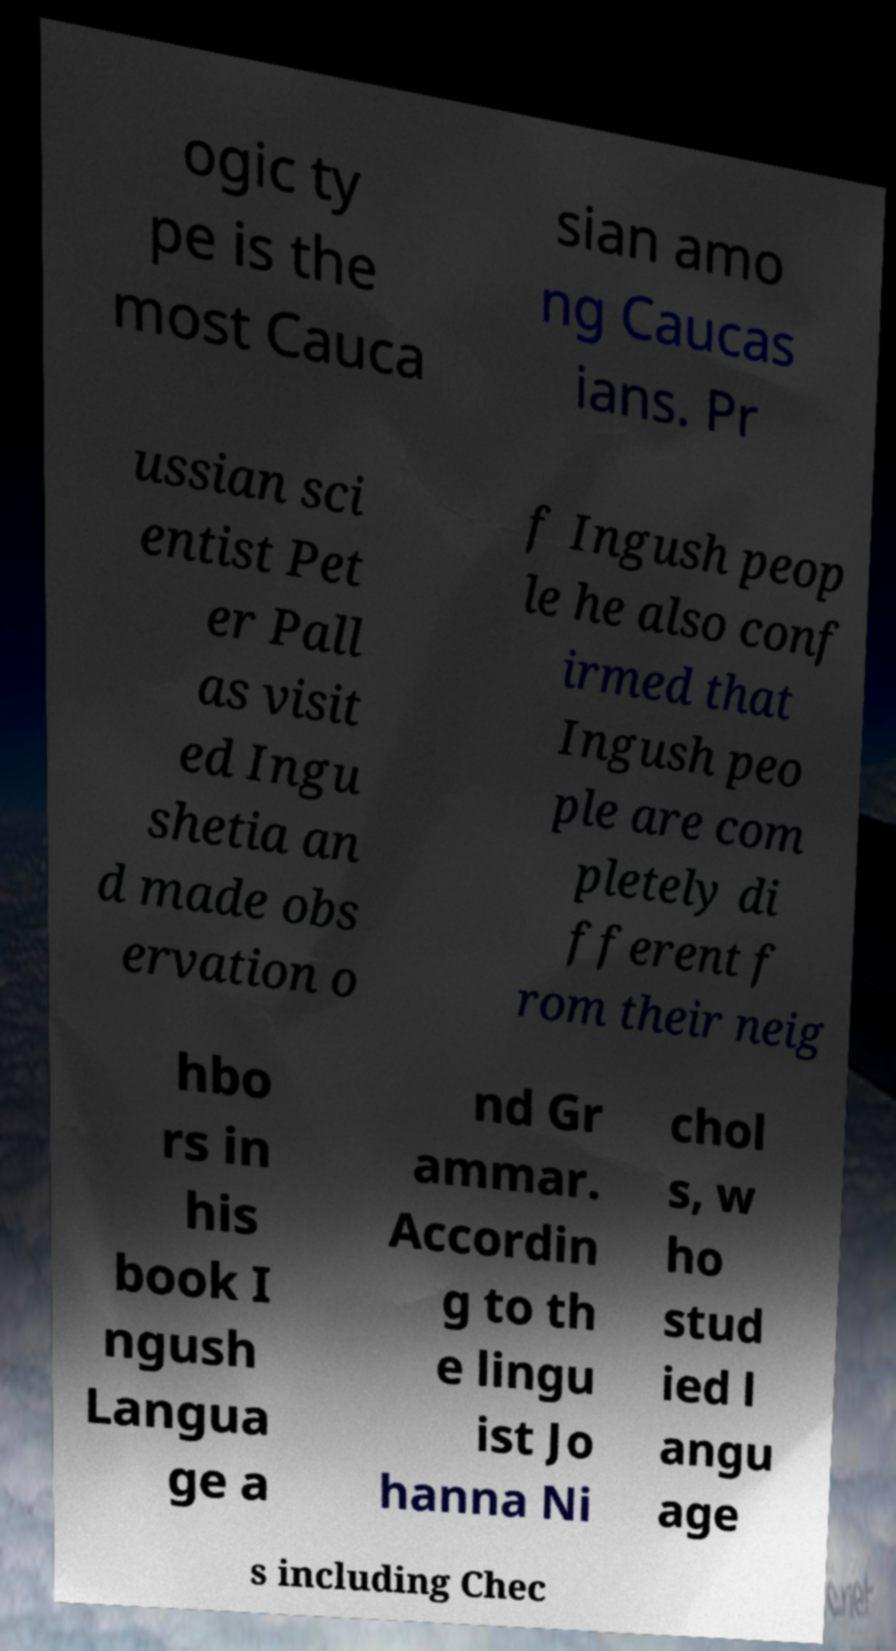Please identify and transcribe the text found in this image. ogic ty pe is the most Cauca sian amo ng Caucas ians. Pr ussian sci entist Pet er Pall as visit ed Ingu shetia an d made obs ervation o f Ingush peop le he also conf irmed that Ingush peo ple are com pletely di fferent f rom their neig hbo rs in his book I ngush Langua ge a nd Gr ammar. Accordin g to th e lingu ist Jo hanna Ni chol s, w ho stud ied l angu age s including Chec 